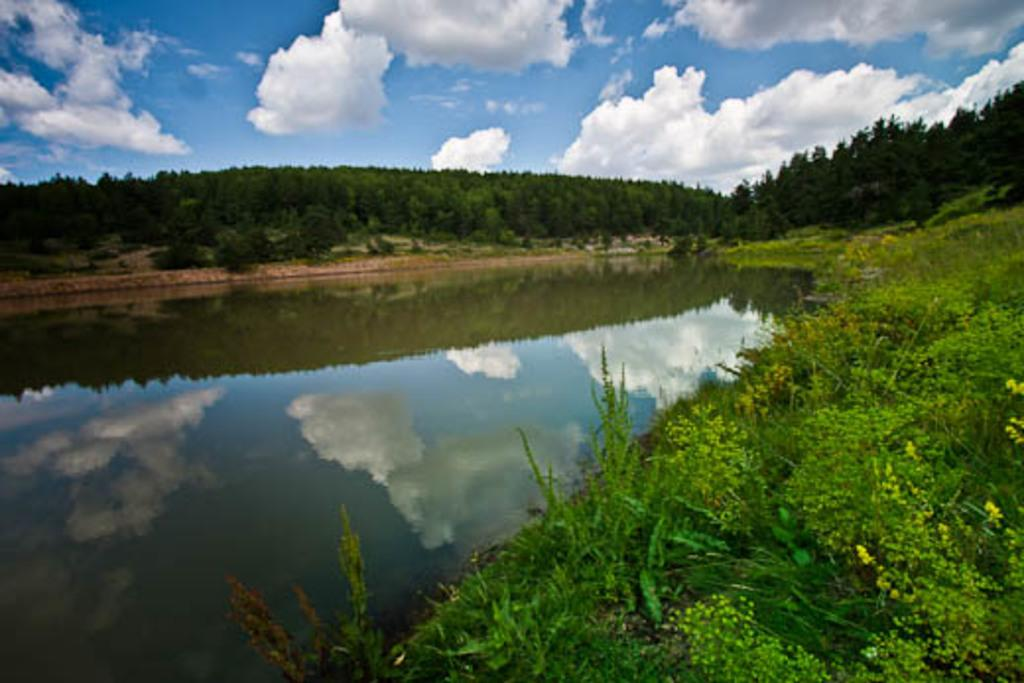What is located in the center of the image? There is water, plants, and grass in the center of the image. What can be seen in the background of the image? There is sky, clouds, and trees visible in the background of the image. What type of vegetation is present in the center of the image? The vegetation in the center of the image includes plants and grass. How many elements can be seen in the background of the image? There are three elements visible in the background: sky, clouds, and trees. Can you tell me how many cords are visible in the image? There are no cords present in the image. What type of magic is being performed in the image? There is no magic or any indication of a magical event in the image. 